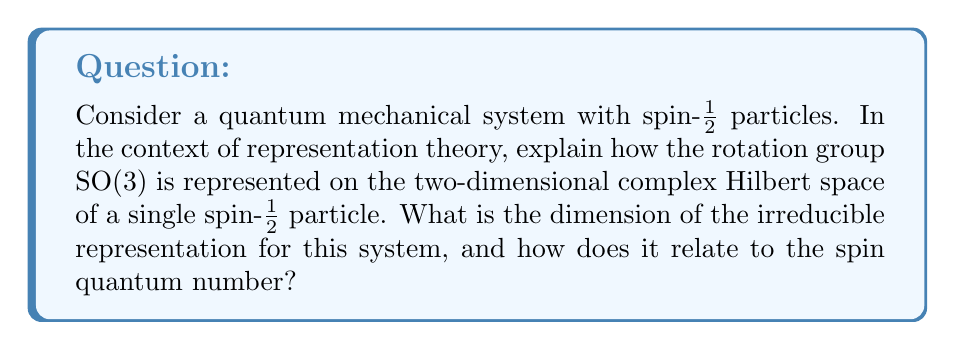Solve this math problem. To address this question, we need to consider the following steps:

1. Understand the connection between SO(3) and SU(2):
   The rotation group SO(3) is closely related to the special unitary group SU(2). In fact, SU(2) is the double cover of SO(3), meaning that there is a 2-to-1 homomorphism from SU(2) to SO(3).

2. Representation of SU(2) for spin-1/2 particles:
   For a spin-1/2 particle, the state space is a two-dimensional complex Hilbert space $\mathcal{H} \cong \mathbb{C}^2$. The group SU(2) acts naturally on this space via its fundamental representation.

3. Generators of the representation:
   The generators of this representation are related to the spin operators $S_x$, $S_y$, and $S_z$, which are given by:

   $$S_x = \frac{\hbar}{2}\sigma_x, \quad S_y = \frac{\hbar}{2}\sigma_y, \quad S_z = \frac{\hbar}{2}\sigma_z$$

   where $\sigma_x$, $\sigma_y$, and $\sigma_z$ are the Pauli matrices.

4. Dimension of the representation:
   The dimension of this representation is 2, as it acts on the two-dimensional Hilbert space $\mathbb{C}^2$.

5. Irreducibility of the representation:
   This representation is irreducible, meaning it cannot be decomposed into smaller invariant subspaces.

6. Relation to spin quantum number:
   For a particle with spin $s$, the dimension of the irreducible representation is given by $2s + 1$. In this case, for a spin-1/2 particle, we have:

   $$\text{dimension} = 2s + 1 = 2(\frac{1}{2}) + 1 = 2$$

   This confirms that the two-dimensional representation we are considering is indeed the correct irreducible representation for a spin-1/2 particle.

7. General formula for angular momentum representations:
   More generally, for a system with total angular momentum quantum number $j$, the dimension of the irreducible representation is $2j + 1$. This formula applies to both orbital and spin angular momentum, as well as their combinations.

In the context of computational physics and material simulations, understanding these representations is crucial for accurately modeling the behavior of quantum mechanical systems, especially when dealing with magnetic properties or spin-dependent phenomena in materials.
Answer: The dimension of the irreducible representation for a spin-1/2 particle is 2. This is related to the spin quantum number $s = \frac{1}{2}$ through the formula $\text{dimension} = 2s + 1 = 2(\frac{1}{2}) + 1 = 2$. 